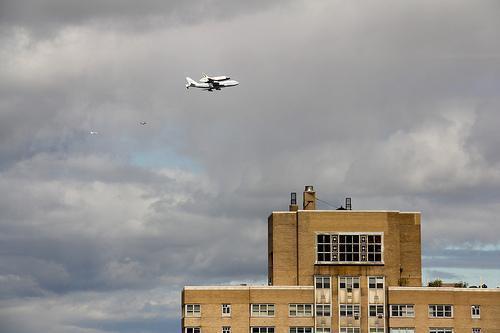How many plane are pictured?
Give a very brief answer. 1. 